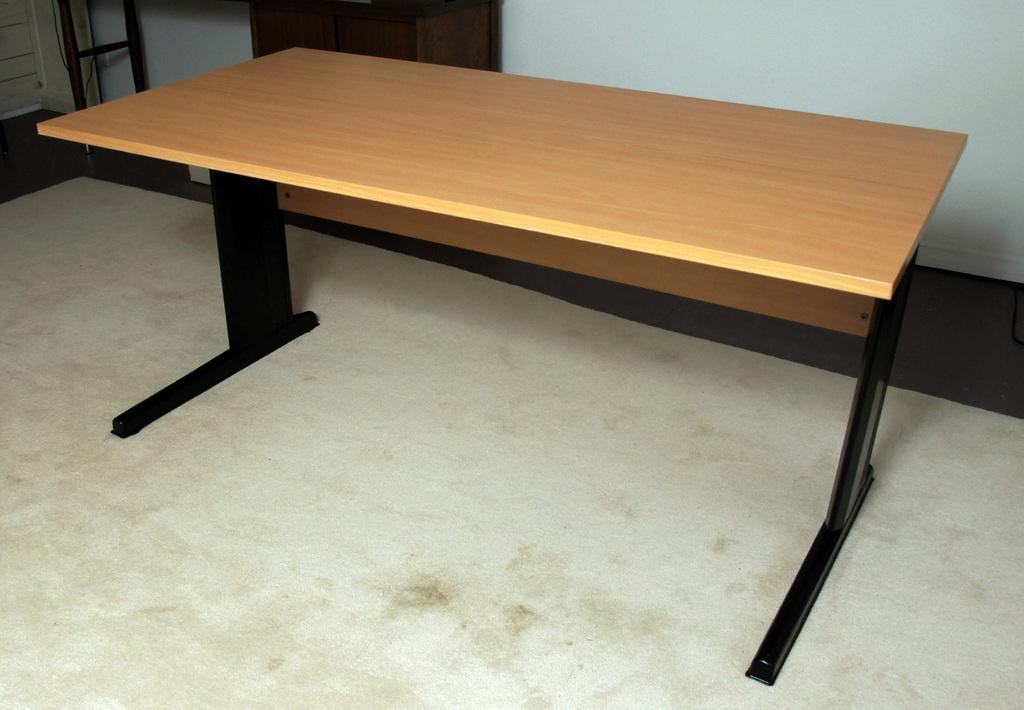How would you summarize this image in a sentence or two? In the center of the image we can see a table. In the background there is a stand and a wall. At the bottom there is a floor. 